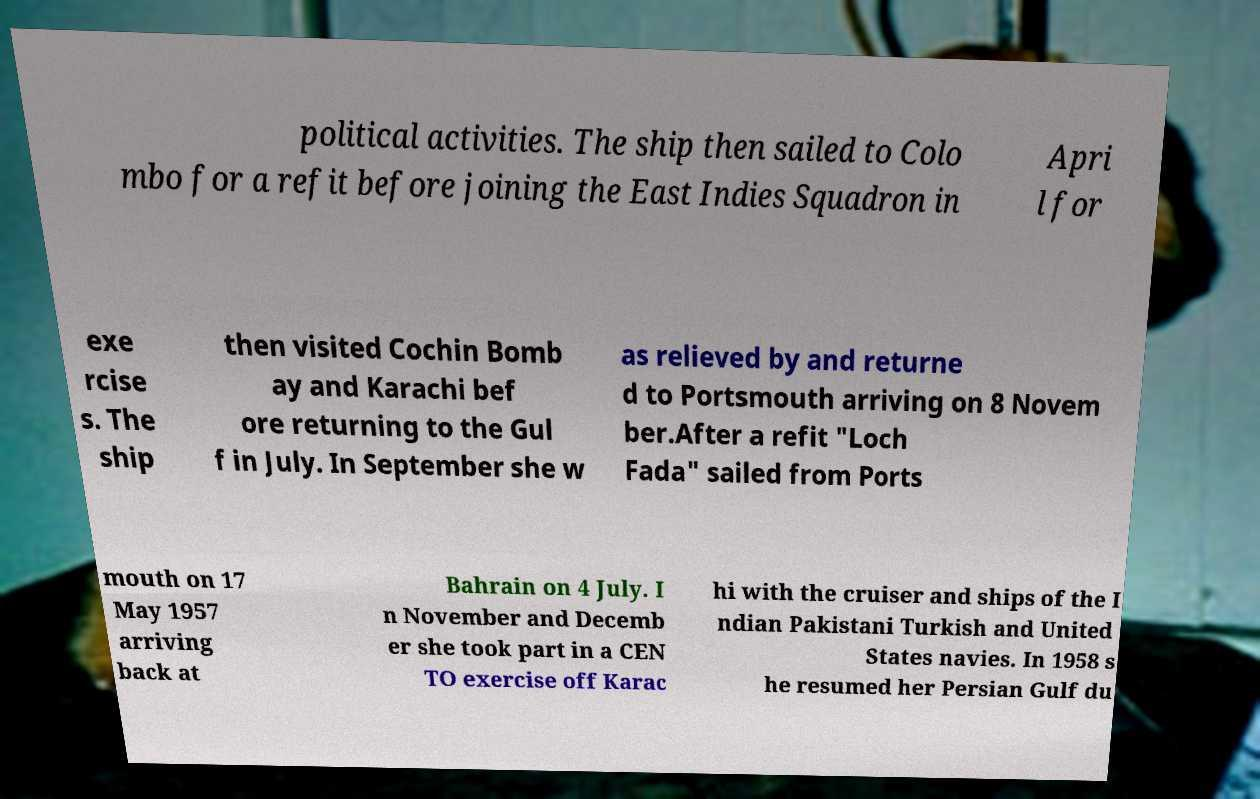What messages or text are displayed in this image? I need them in a readable, typed format. political activities. The ship then sailed to Colo mbo for a refit before joining the East Indies Squadron in Apri l for exe rcise s. The ship then visited Cochin Bomb ay and Karachi bef ore returning to the Gul f in July. In September she w as relieved by and returne d to Portsmouth arriving on 8 Novem ber.After a refit "Loch Fada" sailed from Ports mouth on 17 May 1957 arriving back at Bahrain on 4 July. I n November and Decemb er she took part in a CEN TO exercise off Karac hi with the cruiser and ships of the I ndian Pakistani Turkish and United States navies. In 1958 s he resumed her Persian Gulf du 